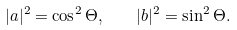<formula> <loc_0><loc_0><loc_500><loc_500>| a | ^ { 2 } = \cos ^ { 2 } \Theta , \quad | b | ^ { 2 } = \sin ^ { 2 } \Theta .</formula> 